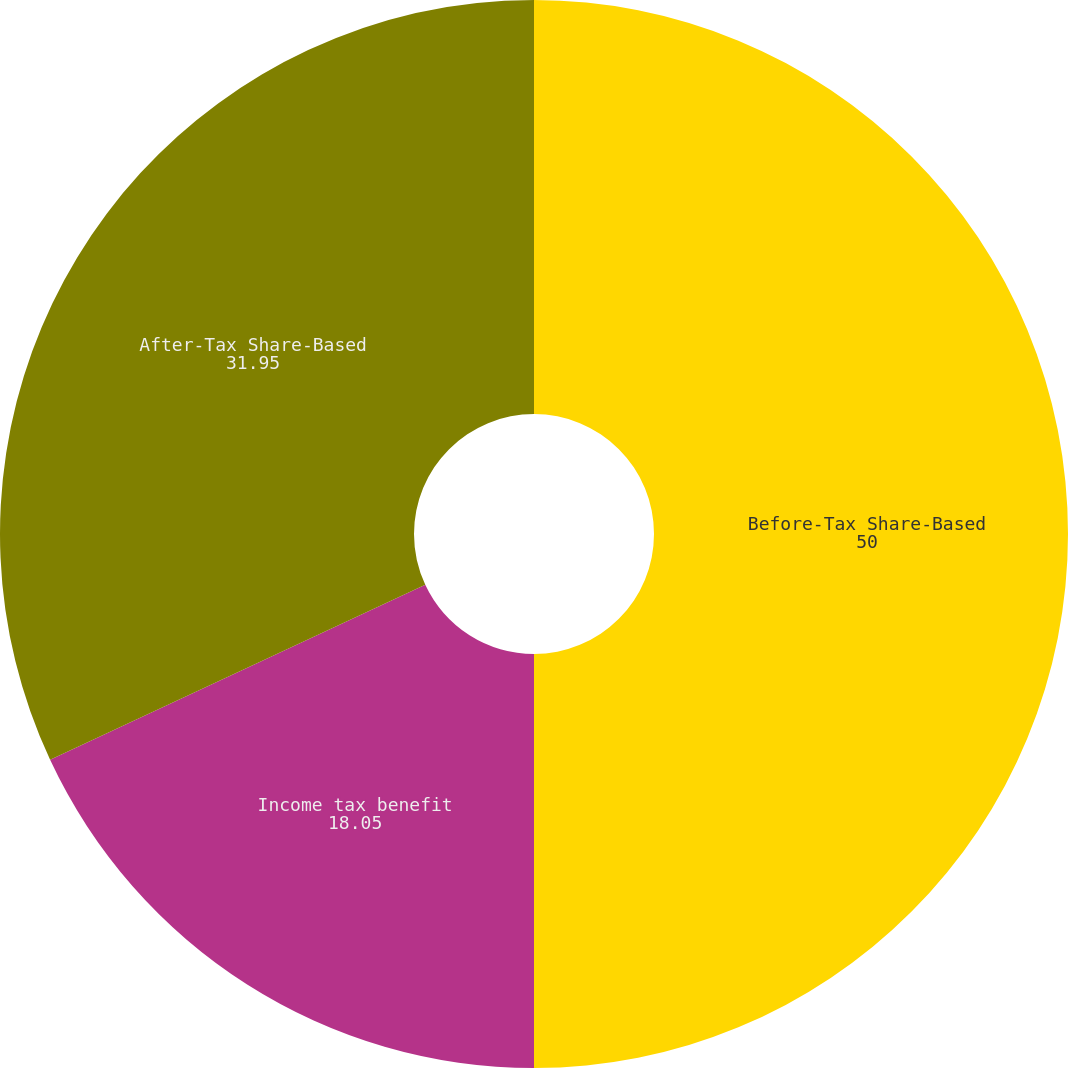<chart> <loc_0><loc_0><loc_500><loc_500><pie_chart><fcel>Before-Tax Share-Based<fcel>Income tax benefit<fcel>After-Tax Share-Based<nl><fcel>50.0%<fcel>18.05%<fcel>31.95%<nl></chart> 